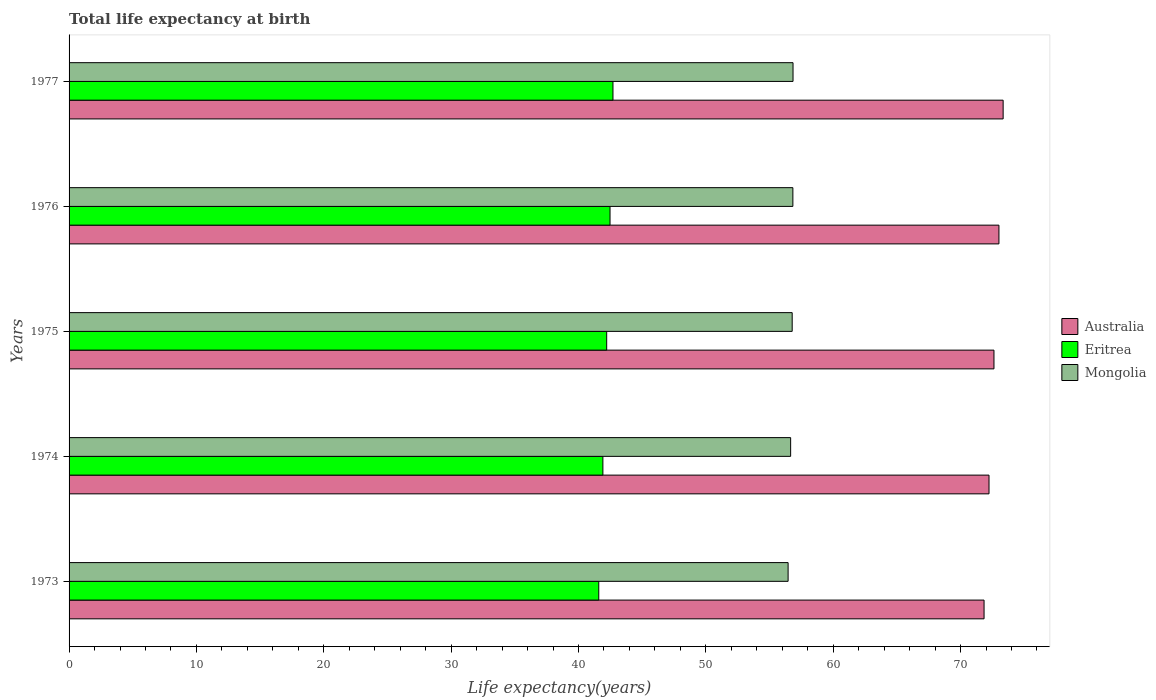How many different coloured bars are there?
Provide a short and direct response. 3. How many groups of bars are there?
Offer a very short reply. 5. How many bars are there on the 2nd tick from the top?
Offer a terse response. 3. How many bars are there on the 3rd tick from the bottom?
Keep it short and to the point. 3. What is the label of the 3rd group of bars from the top?
Ensure brevity in your answer.  1975. What is the life expectancy at birth in in Mongolia in 1977?
Provide a succinct answer. 56.85. Across all years, what is the maximum life expectancy at birth in in Eritrea?
Make the answer very short. 42.71. Across all years, what is the minimum life expectancy at birth in in Mongolia?
Your response must be concise. 56.46. In which year was the life expectancy at birth in in Australia maximum?
Provide a short and direct response. 1977. In which year was the life expectancy at birth in in Australia minimum?
Offer a terse response. 1973. What is the total life expectancy at birth in in Mongolia in the graph?
Provide a short and direct response. 283.58. What is the difference between the life expectancy at birth in in Australia in 1973 and that in 1975?
Keep it short and to the point. -0.78. What is the difference between the life expectancy at birth in in Australia in 1977 and the life expectancy at birth in in Mongolia in 1973?
Make the answer very short. 16.88. What is the average life expectancy at birth in in Eritrea per year?
Ensure brevity in your answer.  42.18. In the year 1975, what is the difference between the life expectancy at birth in in Australia and life expectancy at birth in in Mongolia?
Ensure brevity in your answer.  15.84. What is the ratio of the life expectancy at birth in in Australia in 1974 to that in 1975?
Offer a very short reply. 0.99. Is the difference between the life expectancy at birth in in Australia in 1974 and 1977 greater than the difference between the life expectancy at birth in in Mongolia in 1974 and 1977?
Your answer should be very brief. No. What is the difference between the highest and the second highest life expectancy at birth in in Australia?
Your response must be concise. 0.33. What is the difference between the highest and the lowest life expectancy at birth in in Australia?
Provide a succinct answer. 1.5. In how many years, is the life expectancy at birth in in Eritrea greater than the average life expectancy at birth in in Eritrea taken over all years?
Ensure brevity in your answer.  3. Is the sum of the life expectancy at birth in in Australia in 1973 and 1977 greater than the maximum life expectancy at birth in in Eritrea across all years?
Keep it short and to the point. Yes. What does the 1st bar from the top in 1974 represents?
Give a very brief answer. Mongolia. How many years are there in the graph?
Offer a very short reply. 5. Does the graph contain grids?
Ensure brevity in your answer.  No. How are the legend labels stacked?
Ensure brevity in your answer.  Vertical. What is the title of the graph?
Provide a succinct answer. Total life expectancy at birth. What is the label or title of the X-axis?
Provide a succinct answer. Life expectancy(years). What is the label or title of the Y-axis?
Offer a terse response. Years. What is the Life expectancy(years) of Australia in 1973?
Keep it short and to the point. 71.85. What is the Life expectancy(years) of Eritrea in 1973?
Give a very brief answer. 41.59. What is the Life expectancy(years) of Mongolia in 1973?
Provide a short and direct response. 56.46. What is the Life expectancy(years) of Australia in 1974?
Ensure brevity in your answer.  72.24. What is the Life expectancy(years) in Eritrea in 1974?
Your answer should be compact. 41.92. What is the Life expectancy(years) of Mongolia in 1974?
Provide a succinct answer. 56.66. What is the Life expectancy(years) of Australia in 1975?
Provide a short and direct response. 72.63. What is the Life expectancy(years) in Eritrea in 1975?
Provide a succinct answer. 42.21. What is the Life expectancy(years) of Mongolia in 1975?
Offer a very short reply. 56.78. What is the Life expectancy(years) in Australia in 1976?
Ensure brevity in your answer.  73.01. What is the Life expectancy(years) in Eritrea in 1976?
Keep it short and to the point. 42.48. What is the Life expectancy(years) of Mongolia in 1976?
Make the answer very short. 56.83. What is the Life expectancy(years) of Australia in 1977?
Your answer should be compact. 73.34. What is the Life expectancy(years) in Eritrea in 1977?
Offer a very short reply. 42.71. What is the Life expectancy(years) of Mongolia in 1977?
Your answer should be compact. 56.85. Across all years, what is the maximum Life expectancy(years) of Australia?
Keep it short and to the point. 73.34. Across all years, what is the maximum Life expectancy(years) of Eritrea?
Your response must be concise. 42.71. Across all years, what is the maximum Life expectancy(years) of Mongolia?
Provide a short and direct response. 56.85. Across all years, what is the minimum Life expectancy(years) in Australia?
Your answer should be very brief. 71.85. Across all years, what is the minimum Life expectancy(years) in Eritrea?
Ensure brevity in your answer.  41.59. Across all years, what is the minimum Life expectancy(years) in Mongolia?
Make the answer very short. 56.46. What is the total Life expectancy(years) in Australia in the graph?
Your response must be concise. 363.07. What is the total Life expectancy(years) of Eritrea in the graph?
Offer a very short reply. 210.91. What is the total Life expectancy(years) of Mongolia in the graph?
Provide a short and direct response. 283.58. What is the difference between the Life expectancy(years) of Australia in 1973 and that in 1974?
Your response must be concise. -0.39. What is the difference between the Life expectancy(years) in Eritrea in 1973 and that in 1974?
Offer a very short reply. -0.32. What is the difference between the Life expectancy(years) of Mongolia in 1973 and that in 1974?
Your response must be concise. -0.2. What is the difference between the Life expectancy(years) of Australia in 1973 and that in 1975?
Keep it short and to the point. -0.78. What is the difference between the Life expectancy(years) of Eritrea in 1973 and that in 1975?
Your answer should be very brief. -0.62. What is the difference between the Life expectancy(years) of Mongolia in 1973 and that in 1975?
Your answer should be very brief. -0.32. What is the difference between the Life expectancy(years) in Australia in 1973 and that in 1976?
Give a very brief answer. -1.17. What is the difference between the Life expectancy(years) of Eritrea in 1973 and that in 1976?
Make the answer very short. -0.88. What is the difference between the Life expectancy(years) in Mongolia in 1973 and that in 1976?
Offer a very short reply. -0.37. What is the difference between the Life expectancy(years) of Australia in 1973 and that in 1977?
Provide a succinct answer. -1.5. What is the difference between the Life expectancy(years) in Eritrea in 1973 and that in 1977?
Offer a terse response. -1.12. What is the difference between the Life expectancy(years) of Mongolia in 1973 and that in 1977?
Offer a very short reply. -0.39. What is the difference between the Life expectancy(years) in Australia in 1974 and that in 1975?
Make the answer very short. -0.39. What is the difference between the Life expectancy(years) in Eritrea in 1974 and that in 1975?
Keep it short and to the point. -0.3. What is the difference between the Life expectancy(years) of Mongolia in 1974 and that in 1975?
Provide a succinct answer. -0.12. What is the difference between the Life expectancy(years) in Australia in 1974 and that in 1976?
Your answer should be very brief. -0.78. What is the difference between the Life expectancy(years) of Eritrea in 1974 and that in 1976?
Provide a succinct answer. -0.56. What is the difference between the Life expectancy(years) of Mongolia in 1974 and that in 1976?
Offer a very short reply. -0.17. What is the difference between the Life expectancy(years) of Australia in 1974 and that in 1977?
Make the answer very short. -1.11. What is the difference between the Life expectancy(years) in Eritrea in 1974 and that in 1977?
Your response must be concise. -0.79. What is the difference between the Life expectancy(years) in Mongolia in 1974 and that in 1977?
Ensure brevity in your answer.  -0.19. What is the difference between the Life expectancy(years) in Australia in 1975 and that in 1976?
Your answer should be very brief. -0.39. What is the difference between the Life expectancy(years) of Eritrea in 1975 and that in 1976?
Offer a terse response. -0.26. What is the difference between the Life expectancy(years) in Mongolia in 1975 and that in 1976?
Keep it short and to the point. -0.05. What is the difference between the Life expectancy(years) in Australia in 1975 and that in 1977?
Your response must be concise. -0.72. What is the difference between the Life expectancy(years) in Eritrea in 1975 and that in 1977?
Offer a terse response. -0.49. What is the difference between the Life expectancy(years) in Mongolia in 1975 and that in 1977?
Offer a very short reply. -0.07. What is the difference between the Life expectancy(years) in Australia in 1976 and that in 1977?
Your answer should be very brief. -0.33. What is the difference between the Life expectancy(years) of Eritrea in 1976 and that in 1977?
Provide a short and direct response. -0.23. What is the difference between the Life expectancy(years) of Mongolia in 1976 and that in 1977?
Provide a short and direct response. -0.01. What is the difference between the Life expectancy(years) of Australia in 1973 and the Life expectancy(years) of Eritrea in 1974?
Your response must be concise. 29.93. What is the difference between the Life expectancy(years) of Australia in 1973 and the Life expectancy(years) of Mongolia in 1974?
Keep it short and to the point. 15.19. What is the difference between the Life expectancy(years) of Eritrea in 1973 and the Life expectancy(years) of Mongolia in 1974?
Make the answer very short. -15.07. What is the difference between the Life expectancy(years) in Australia in 1973 and the Life expectancy(years) in Eritrea in 1975?
Your response must be concise. 29.63. What is the difference between the Life expectancy(years) of Australia in 1973 and the Life expectancy(years) of Mongolia in 1975?
Provide a short and direct response. 15.07. What is the difference between the Life expectancy(years) of Eritrea in 1973 and the Life expectancy(years) of Mongolia in 1975?
Provide a succinct answer. -15.19. What is the difference between the Life expectancy(years) of Australia in 1973 and the Life expectancy(years) of Eritrea in 1976?
Your answer should be very brief. 29.37. What is the difference between the Life expectancy(years) in Australia in 1973 and the Life expectancy(years) in Mongolia in 1976?
Keep it short and to the point. 15.01. What is the difference between the Life expectancy(years) of Eritrea in 1973 and the Life expectancy(years) of Mongolia in 1976?
Offer a terse response. -15.24. What is the difference between the Life expectancy(years) in Australia in 1973 and the Life expectancy(years) in Eritrea in 1977?
Offer a very short reply. 29.14. What is the difference between the Life expectancy(years) in Australia in 1973 and the Life expectancy(years) in Mongolia in 1977?
Make the answer very short. 15. What is the difference between the Life expectancy(years) in Eritrea in 1973 and the Life expectancy(years) in Mongolia in 1977?
Ensure brevity in your answer.  -15.25. What is the difference between the Life expectancy(years) of Australia in 1974 and the Life expectancy(years) of Eritrea in 1975?
Ensure brevity in your answer.  30.02. What is the difference between the Life expectancy(years) of Australia in 1974 and the Life expectancy(years) of Mongolia in 1975?
Offer a terse response. 15.46. What is the difference between the Life expectancy(years) in Eritrea in 1974 and the Life expectancy(years) in Mongolia in 1975?
Provide a short and direct response. -14.86. What is the difference between the Life expectancy(years) in Australia in 1974 and the Life expectancy(years) in Eritrea in 1976?
Ensure brevity in your answer.  29.76. What is the difference between the Life expectancy(years) of Australia in 1974 and the Life expectancy(years) of Mongolia in 1976?
Make the answer very short. 15.4. What is the difference between the Life expectancy(years) of Eritrea in 1974 and the Life expectancy(years) of Mongolia in 1976?
Keep it short and to the point. -14.92. What is the difference between the Life expectancy(years) of Australia in 1974 and the Life expectancy(years) of Eritrea in 1977?
Offer a terse response. 29.53. What is the difference between the Life expectancy(years) of Australia in 1974 and the Life expectancy(years) of Mongolia in 1977?
Your answer should be compact. 15.39. What is the difference between the Life expectancy(years) in Eritrea in 1974 and the Life expectancy(years) in Mongolia in 1977?
Your answer should be compact. -14.93. What is the difference between the Life expectancy(years) of Australia in 1975 and the Life expectancy(years) of Eritrea in 1976?
Keep it short and to the point. 30.15. What is the difference between the Life expectancy(years) in Australia in 1975 and the Life expectancy(years) in Mongolia in 1976?
Your answer should be very brief. 15.79. What is the difference between the Life expectancy(years) in Eritrea in 1975 and the Life expectancy(years) in Mongolia in 1976?
Your response must be concise. -14.62. What is the difference between the Life expectancy(years) in Australia in 1975 and the Life expectancy(years) in Eritrea in 1977?
Ensure brevity in your answer.  29.92. What is the difference between the Life expectancy(years) in Australia in 1975 and the Life expectancy(years) in Mongolia in 1977?
Keep it short and to the point. 15.78. What is the difference between the Life expectancy(years) of Eritrea in 1975 and the Life expectancy(years) of Mongolia in 1977?
Offer a very short reply. -14.63. What is the difference between the Life expectancy(years) in Australia in 1976 and the Life expectancy(years) in Eritrea in 1977?
Provide a succinct answer. 30.31. What is the difference between the Life expectancy(years) in Australia in 1976 and the Life expectancy(years) in Mongolia in 1977?
Keep it short and to the point. 16.17. What is the difference between the Life expectancy(years) in Eritrea in 1976 and the Life expectancy(years) in Mongolia in 1977?
Keep it short and to the point. -14.37. What is the average Life expectancy(years) of Australia per year?
Your answer should be compact. 72.61. What is the average Life expectancy(years) of Eritrea per year?
Offer a very short reply. 42.18. What is the average Life expectancy(years) in Mongolia per year?
Provide a short and direct response. 56.72. In the year 1973, what is the difference between the Life expectancy(years) in Australia and Life expectancy(years) in Eritrea?
Give a very brief answer. 30.25. In the year 1973, what is the difference between the Life expectancy(years) of Australia and Life expectancy(years) of Mongolia?
Give a very brief answer. 15.39. In the year 1973, what is the difference between the Life expectancy(years) of Eritrea and Life expectancy(years) of Mongolia?
Your response must be concise. -14.87. In the year 1974, what is the difference between the Life expectancy(years) of Australia and Life expectancy(years) of Eritrea?
Make the answer very short. 30.32. In the year 1974, what is the difference between the Life expectancy(years) in Australia and Life expectancy(years) in Mongolia?
Your response must be concise. 15.58. In the year 1974, what is the difference between the Life expectancy(years) of Eritrea and Life expectancy(years) of Mongolia?
Provide a succinct answer. -14.74. In the year 1975, what is the difference between the Life expectancy(years) in Australia and Life expectancy(years) in Eritrea?
Make the answer very short. 30.41. In the year 1975, what is the difference between the Life expectancy(years) in Australia and Life expectancy(years) in Mongolia?
Offer a very short reply. 15.84. In the year 1975, what is the difference between the Life expectancy(years) in Eritrea and Life expectancy(years) in Mongolia?
Give a very brief answer. -14.57. In the year 1976, what is the difference between the Life expectancy(years) in Australia and Life expectancy(years) in Eritrea?
Your answer should be compact. 30.54. In the year 1976, what is the difference between the Life expectancy(years) of Australia and Life expectancy(years) of Mongolia?
Provide a short and direct response. 16.18. In the year 1976, what is the difference between the Life expectancy(years) of Eritrea and Life expectancy(years) of Mongolia?
Provide a succinct answer. -14.36. In the year 1977, what is the difference between the Life expectancy(years) in Australia and Life expectancy(years) in Eritrea?
Your response must be concise. 30.64. In the year 1977, what is the difference between the Life expectancy(years) of Australia and Life expectancy(years) of Mongolia?
Your response must be concise. 16.5. In the year 1977, what is the difference between the Life expectancy(years) of Eritrea and Life expectancy(years) of Mongolia?
Give a very brief answer. -14.14. What is the ratio of the Life expectancy(years) in Australia in 1973 to that in 1974?
Offer a very short reply. 0.99. What is the ratio of the Life expectancy(years) in Eritrea in 1973 to that in 1974?
Offer a terse response. 0.99. What is the ratio of the Life expectancy(years) in Australia in 1973 to that in 1975?
Provide a succinct answer. 0.99. What is the ratio of the Life expectancy(years) in Mongolia in 1973 to that in 1975?
Keep it short and to the point. 0.99. What is the ratio of the Life expectancy(years) of Eritrea in 1973 to that in 1976?
Ensure brevity in your answer.  0.98. What is the ratio of the Life expectancy(years) of Mongolia in 1973 to that in 1976?
Offer a very short reply. 0.99. What is the ratio of the Life expectancy(years) in Australia in 1973 to that in 1977?
Make the answer very short. 0.98. What is the ratio of the Life expectancy(years) in Eritrea in 1973 to that in 1977?
Offer a very short reply. 0.97. What is the ratio of the Life expectancy(years) of Mongolia in 1973 to that in 1977?
Keep it short and to the point. 0.99. What is the ratio of the Life expectancy(years) of Eritrea in 1974 to that in 1975?
Provide a succinct answer. 0.99. What is the ratio of the Life expectancy(years) in Australia in 1974 to that in 1976?
Your answer should be very brief. 0.99. What is the ratio of the Life expectancy(years) of Mongolia in 1974 to that in 1976?
Ensure brevity in your answer.  1. What is the ratio of the Life expectancy(years) of Australia in 1974 to that in 1977?
Keep it short and to the point. 0.98. What is the ratio of the Life expectancy(years) of Eritrea in 1974 to that in 1977?
Ensure brevity in your answer.  0.98. What is the ratio of the Life expectancy(years) in Australia in 1975 to that in 1976?
Provide a succinct answer. 0.99. What is the ratio of the Life expectancy(years) of Mongolia in 1975 to that in 1976?
Ensure brevity in your answer.  1. What is the ratio of the Life expectancy(years) of Australia in 1975 to that in 1977?
Your answer should be very brief. 0.99. What is the ratio of the Life expectancy(years) of Eritrea in 1975 to that in 1977?
Your answer should be compact. 0.99. What is the ratio of the Life expectancy(years) in Australia in 1976 to that in 1977?
Ensure brevity in your answer.  1. What is the ratio of the Life expectancy(years) in Mongolia in 1976 to that in 1977?
Your answer should be compact. 1. What is the difference between the highest and the second highest Life expectancy(years) of Australia?
Your answer should be compact. 0.33. What is the difference between the highest and the second highest Life expectancy(years) in Eritrea?
Keep it short and to the point. 0.23. What is the difference between the highest and the second highest Life expectancy(years) in Mongolia?
Your answer should be very brief. 0.01. What is the difference between the highest and the lowest Life expectancy(years) in Australia?
Your answer should be compact. 1.5. What is the difference between the highest and the lowest Life expectancy(years) in Eritrea?
Offer a terse response. 1.12. What is the difference between the highest and the lowest Life expectancy(years) of Mongolia?
Offer a terse response. 0.39. 